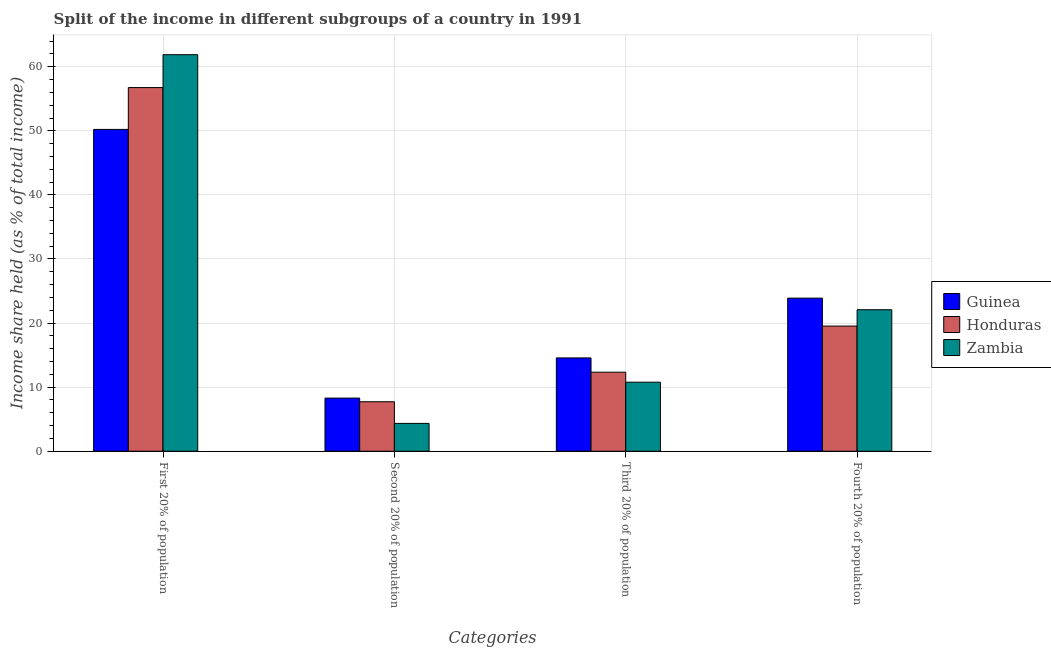How many different coloured bars are there?
Make the answer very short. 3. How many groups of bars are there?
Ensure brevity in your answer.  4. Are the number of bars per tick equal to the number of legend labels?
Ensure brevity in your answer.  Yes. How many bars are there on the 2nd tick from the left?
Offer a terse response. 3. What is the label of the 2nd group of bars from the left?
Your response must be concise. Second 20% of population. What is the share of the income held by third 20% of the population in Honduras?
Ensure brevity in your answer.  12.33. Across all countries, what is the maximum share of the income held by first 20% of the population?
Your answer should be compact. 61.88. Across all countries, what is the minimum share of the income held by third 20% of the population?
Ensure brevity in your answer.  10.77. In which country was the share of the income held by first 20% of the population maximum?
Your answer should be compact. Zambia. In which country was the share of the income held by third 20% of the population minimum?
Provide a short and direct response. Zambia. What is the total share of the income held by third 20% of the population in the graph?
Your response must be concise. 37.66. What is the difference between the share of the income held by second 20% of the population in Guinea and that in Zambia?
Your answer should be compact. 3.95. What is the difference between the share of the income held by first 20% of the population in Guinea and the share of the income held by fourth 20% of the population in Zambia?
Ensure brevity in your answer.  28.14. What is the average share of the income held by third 20% of the population per country?
Your response must be concise. 12.55. What is the difference between the share of the income held by first 20% of the population and share of the income held by third 20% of the population in Guinea?
Your answer should be very brief. 35.66. What is the ratio of the share of the income held by fourth 20% of the population in Guinea to that in Zambia?
Offer a terse response. 1.08. Is the share of the income held by fourth 20% of the population in Honduras less than that in Guinea?
Offer a very short reply. Yes. What is the difference between the highest and the second highest share of the income held by third 20% of the population?
Ensure brevity in your answer.  2.23. What is the difference between the highest and the lowest share of the income held by second 20% of the population?
Make the answer very short. 3.95. What does the 3rd bar from the left in Third 20% of population represents?
Give a very brief answer. Zambia. What does the 1st bar from the right in First 20% of population represents?
Keep it short and to the point. Zambia. Is it the case that in every country, the sum of the share of the income held by first 20% of the population and share of the income held by second 20% of the population is greater than the share of the income held by third 20% of the population?
Keep it short and to the point. Yes. Where does the legend appear in the graph?
Your response must be concise. Center right. How many legend labels are there?
Ensure brevity in your answer.  3. How are the legend labels stacked?
Offer a very short reply. Vertical. What is the title of the graph?
Ensure brevity in your answer.  Split of the income in different subgroups of a country in 1991. What is the label or title of the X-axis?
Make the answer very short. Categories. What is the label or title of the Y-axis?
Give a very brief answer. Income share held (as % of total income). What is the Income share held (as % of total income) of Guinea in First 20% of population?
Give a very brief answer. 50.22. What is the Income share held (as % of total income) of Honduras in First 20% of population?
Your response must be concise. 56.75. What is the Income share held (as % of total income) in Zambia in First 20% of population?
Provide a succinct answer. 61.88. What is the Income share held (as % of total income) in Guinea in Second 20% of population?
Your answer should be very brief. 8.29. What is the Income share held (as % of total income) in Honduras in Second 20% of population?
Provide a short and direct response. 7.72. What is the Income share held (as % of total income) in Zambia in Second 20% of population?
Ensure brevity in your answer.  4.34. What is the Income share held (as % of total income) of Guinea in Third 20% of population?
Give a very brief answer. 14.56. What is the Income share held (as % of total income) in Honduras in Third 20% of population?
Your answer should be very brief. 12.33. What is the Income share held (as % of total income) of Zambia in Third 20% of population?
Give a very brief answer. 10.77. What is the Income share held (as % of total income) in Guinea in Fourth 20% of population?
Provide a short and direct response. 23.89. What is the Income share held (as % of total income) of Honduras in Fourth 20% of population?
Your answer should be compact. 19.53. What is the Income share held (as % of total income) in Zambia in Fourth 20% of population?
Ensure brevity in your answer.  22.08. Across all Categories, what is the maximum Income share held (as % of total income) of Guinea?
Ensure brevity in your answer.  50.22. Across all Categories, what is the maximum Income share held (as % of total income) of Honduras?
Your answer should be compact. 56.75. Across all Categories, what is the maximum Income share held (as % of total income) of Zambia?
Offer a terse response. 61.88. Across all Categories, what is the minimum Income share held (as % of total income) of Guinea?
Offer a terse response. 8.29. Across all Categories, what is the minimum Income share held (as % of total income) of Honduras?
Your answer should be very brief. 7.72. Across all Categories, what is the minimum Income share held (as % of total income) of Zambia?
Offer a terse response. 4.34. What is the total Income share held (as % of total income) in Guinea in the graph?
Your answer should be very brief. 96.96. What is the total Income share held (as % of total income) in Honduras in the graph?
Provide a short and direct response. 96.33. What is the total Income share held (as % of total income) of Zambia in the graph?
Ensure brevity in your answer.  99.07. What is the difference between the Income share held (as % of total income) of Guinea in First 20% of population and that in Second 20% of population?
Provide a short and direct response. 41.93. What is the difference between the Income share held (as % of total income) of Honduras in First 20% of population and that in Second 20% of population?
Offer a very short reply. 49.03. What is the difference between the Income share held (as % of total income) in Zambia in First 20% of population and that in Second 20% of population?
Offer a terse response. 57.54. What is the difference between the Income share held (as % of total income) in Guinea in First 20% of population and that in Third 20% of population?
Your response must be concise. 35.66. What is the difference between the Income share held (as % of total income) of Honduras in First 20% of population and that in Third 20% of population?
Your answer should be very brief. 44.42. What is the difference between the Income share held (as % of total income) of Zambia in First 20% of population and that in Third 20% of population?
Provide a short and direct response. 51.11. What is the difference between the Income share held (as % of total income) of Guinea in First 20% of population and that in Fourth 20% of population?
Offer a terse response. 26.33. What is the difference between the Income share held (as % of total income) in Honduras in First 20% of population and that in Fourth 20% of population?
Provide a short and direct response. 37.22. What is the difference between the Income share held (as % of total income) of Zambia in First 20% of population and that in Fourth 20% of population?
Keep it short and to the point. 39.8. What is the difference between the Income share held (as % of total income) of Guinea in Second 20% of population and that in Third 20% of population?
Your answer should be very brief. -6.27. What is the difference between the Income share held (as % of total income) of Honduras in Second 20% of population and that in Third 20% of population?
Make the answer very short. -4.61. What is the difference between the Income share held (as % of total income) of Zambia in Second 20% of population and that in Third 20% of population?
Ensure brevity in your answer.  -6.43. What is the difference between the Income share held (as % of total income) of Guinea in Second 20% of population and that in Fourth 20% of population?
Offer a terse response. -15.6. What is the difference between the Income share held (as % of total income) in Honduras in Second 20% of population and that in Fourth 20% of population?
Ensure brevity in your answer.  -11.81. What is the difference between the Income share held (as % of total income) in Zambia in Second 20% of population and that in Fourth 20% of population?
Provide a succinct answer. -17.74. What is the difference between the Income share held (as % of total income) in Guinea in Third 20% of population and that in Fourth 20% of population?
Ensure brevity in your answer.  -9.33. What is the difference between the Income share held (as % of total income) of Honduras in Third 20% of population and that in Fourth 20% of population?
Your response must be concise. -7.2. What is the difference between the Income share held (as % of total income) in Zambia in Third 20% of population and that in Fourth 20% of population?
Your answer should be very brief. -11.31. What is the difference between the Income share held (as % of total income) of Guinea in First 20% of population and the Income share held (as % of total income) of Honduras in Second 20% of population?
Offer a terse response. 42.5. What is the difference between the Income share held (as % of total income) of Guinea in First 20% of population and the Income share held (as % of total income) of Zambia in Second 20% of population?
Provide a short and direct response. 45.88. What is the difference between the Income share held (as % of total income) in Honduras in First 20% of population and the Income share held (as % of total income) in Zambia in Second 20% of population?
Make the answer very short. 52.41. What is the difference between the Income share held (as % of total income) in Guinea in First 20% of population and the Income share held (as % of total income) in Honduras in Third 20% of population?
Ensure brevity in your answer.  37.89. What is the difference between the Income share held (as % of total income) of Guinea in First 20% of population and the Income share held (as % of total income) of Zambia in Third 20% of population?
Ensure brevity in your answer.  39.45. What is the difference between the Income share held (as % of total income) of Honduras in First 20% of population and the Income share held (as % of total income) of Zambia in Third 20% of population?
Your answer should be compact. 45.98. What is the difference between the Income share held (as % of total income) of Guinea in First 20% of population and the Income share held (as % of total income) of Honduras in Fourth 20% of population?
Your answer should be compact. 30.69. What is the difference between the Income share held (as % of total income) of Guinea in First 20% of population and the Income share held (as % of total income) of Zambia in Fourth 20% of population?
Offer a terse response. 28.14. What is the difference between the Income share held (as % of total income) in Honduras in First 20% of population and the Income share held (as % of total income) in Zambia in Fourth 20% of population?
Keep it short and to the point. 34.67. What is the difference between the Income share held (as % of total income) in Guinea in Second 20% of population and the Income share held (as % of total income) in Honduras in Third 20% of population?
Offer a terse response. -4.04. What is the difference between the Income share held (as % of total income) of Guinea in Second 20% of population and the Income share held (as % of total income) of Zambia in Third 20% of population?
Provide a succinct answer. -2.48. What is the difference between the Income share held (as % of total income) of Honduras in Second 20% of population and the Income share held (as % of total income) of Zambia in Third 20% of population?
Ensure brevity in your answer.  -3.05. What is the difference between the Income share held (as % of total income) of Guinea in Second 20% of population and the Income share held (as % of total income) of Honduras in Fourth 20% of population?
Give a very brief answer. -11.24. What is the difference between the Income share held (as % of total income) in Guinea in Second 20% of population and the Income share held (as % of total income) in Zambia in Fourth 20% of population?
Offer a very short reply. -13.79. What is the difference between the Income share held (as % of total income) of Honduras in Second 20% of population and the Income share held (as % of total income) of Zambia in Fourth 20% of population?
Offer a terse response. -14.36. What is the difference between the Income share held (as % of total income) of Guinea in Third 20% of population and the Income share held (as % of total income) of Honduras in Fourth 20% of population?
Provide a succinct answer. -4.97. What is the difference between the Income share held (as % of total income) in Guinea in Third 20% of population and the Income share held (as % of total income) in Zambia in Fourth 20% of population?
Your response must be concise. -7.52. What is the difference between the Income share held (as % of total income) in Honduras in Third 20% of population and the Income share held (as % of total income) in Zambia in Fourth 20% of population?
Provide a short and direct response. -9.75. What is the average Income share held (as % of total income) in Guinea per Categories?
Give a very brief answer. 24.24. What is the average Income share held (as % of total income) of Honduras per Categories?
Offer a terse response. 24.08. What is the average Income share held (as % of total income) in Zambia per Categories?
Your response must be concise. 24.77. What is the difference between the Income share held (as % of total income) in Guinea and Income share held (as % of total income) in Honduras in First 20% of population?
Provide a short and direct response. -6.53. What is the difference between the Income share held (as % of total income) of Guinea and Income share held (as % of total income) of Zambia in First 20% of population?
Give a very brief answer. -11.66. What is the difference between the Income share held (as % of total income) in Honduras and Income share held (as % of total income) in Zambia in First 20% of population?
Your answer should be very brief. -5.13. What is the difference between the Income share held (as % of total income) of Guinea and Income share held (as % of total income) of Honduras in Second 20% of population?
Your answer should be very brief. 0.57. What is the difference between the Income share held (as % of total income) of Guinea and Income share held (as % of total income) of Zambia in Second 20% of population?
Your answer should be very brief. 3.95. What is the difference between the Income share held (as % of total income) of Honduras and Income share held (as % of total income) of Zambia in Second 20% of population?
Your answer should be very brief. 3.38. What is the difference between the Income share held (as % of total income) of Guinea and Income share held (as % of total income) of Honduras in Third 20% of population?
Provide a short and direct response. 2.23. What is the difference between the Income share held (as % of total income) in Guinea and Income share held (as % of total income) in Zambia in Third 20% of population?
Your answer should be very brief. 3.79. What is the difference between the Income share held (as % of total income) in Honduras and Income share held (as % of total income) in Zambia in Third 20% of population?
Your answer should be compact. 1.56. What is the difference between the Income share held (as % of total income) of Guinea and Income share held (as % of total income) of Honduras in Fourth 20% of population?
Your response must be concise. 4.36. What is the difference between the Income share held (as % of total income) of Guinea and Income share held (as % of total income) of Zambia in Fourth 20% of population?
Offer a very short reply. 1.81. What is the difference between the Income share held (as % of total income) in Honduras and Income share held (as % of total income) in Zambia in Fourth 20% of population?
Your answer should be very brief. -2.55. What is the ratio of the Income share held (as % of total income) in Guinea in First 20% of population to that in Second 20% of population?
Offer a terse response. 6.06. What is the ratio of the Income share held (as % of total income) of Honduras in First 20% of population to that in Second 20% of population?
Your answer should be compact. 7.35. What is the ratio of the Income share held (as % of total income) in Zambia in First 20% of population to that in Second 20% of population?
Provide a succinct answer. 14.26. What is the ratio of the Income share held (as % of total income) in Guinea in First 20% of population to that in Third 20% of population?
Provide a short and direct response. 3.45. What is the ratio of the Income share held (as % of total income) in Honduras in First 20% of population to that in Third 20% of population?
Ensure brevity in your answer.  4.6. What is the ratio of the Income share held (as % of total income) in Zambia in First 20% of population to that in Third 20% of population?
Give a very brief answer. 5.75. What is the ratio of the Income share held (as % of total income) in Guinea in First 20% of population to that in Fourth 20% of population?
Your answer should be compact. 2.1. What is the ratio of the Income share held (as % of total income) of Honduras in First 20% of population to that in Fourth 20% of population?
Keep it short and to the point. 2.91. What is the ratio of the Income share held (as % of total income) of Zambia in First 20% of population to that in Fourth 20% of population?
Provide a succinct answer. 2.8. What is the ratio of the Income share held (as % of total income) in Guinea in Second 20% of population to that in Third 20% of population?
Keep it short and to the point. 0.57. What is the ratio of the Income share held (as % of total income) in Honduras in Second 20% of population to that in Third 20% of population?
Provide a short and direct response. 0.63. What is the ratio of the Income share held (as % of total income) in Zambia in Second 20% of population to that in Third 20% of population?
Give a very brief answer. 0.4. What is the ratio of the Income share held (as % of total income) in Guinea in Second 20% of population to that in Fourth 20% of population?
Ensure brevity in your answer.  0.35. What is the ratio of the Income share held (as % of total income) of Honduras in Second 20% of population to that in Fourth 20% of population?
Offer a terse response. 0.4. What is the ratio of the Income share held (as % of total income) in Zambia in Second 20% of population to that in Fourth 20% of population?
Your answer should be compact. 0.2. What is the ratio of the Income share held (as % of total income) in Guinea in Third 20% of population to that in Fourth 20% of population?
Give a very brief answer. 0.61. What is the ratio of the Income share held (as % of total income) of Honduras in Third 20% of population to that in Fourth 20% of population?
Offer a terse response. 0.63. What is the ratio of the Income share held (as % of total income) of Zambia in Third 20% of population to that in Fourth 20% of population?
Your answer should be compact. 0.49. What is the difference between the highest and the second highest Income share held (as % of total income) in Guinea?
Provide a succinct answer. 26.33. What is the difference between the highest and the second highest Income share held (as % of total income) of Honduras?
Offer a terse response. 37.22. What is the difference between the highest and the second highest Income share held (as % of total income) in Zambia?
Keep it short and to the point. 39.8. What is the difference between the highest and the lowest Income share held (as % of total income) of Guinea?
Your answer should be very brief. 41.93. What is the difference between the highest and the lowest Income share held (as % of total income) of Honduras?
Provide a short and direct response. 49.03. What is the difference between the highest and the lowest Income share held (as % of total income) of Zambia?
Provide a succinct answer. 57.54. 